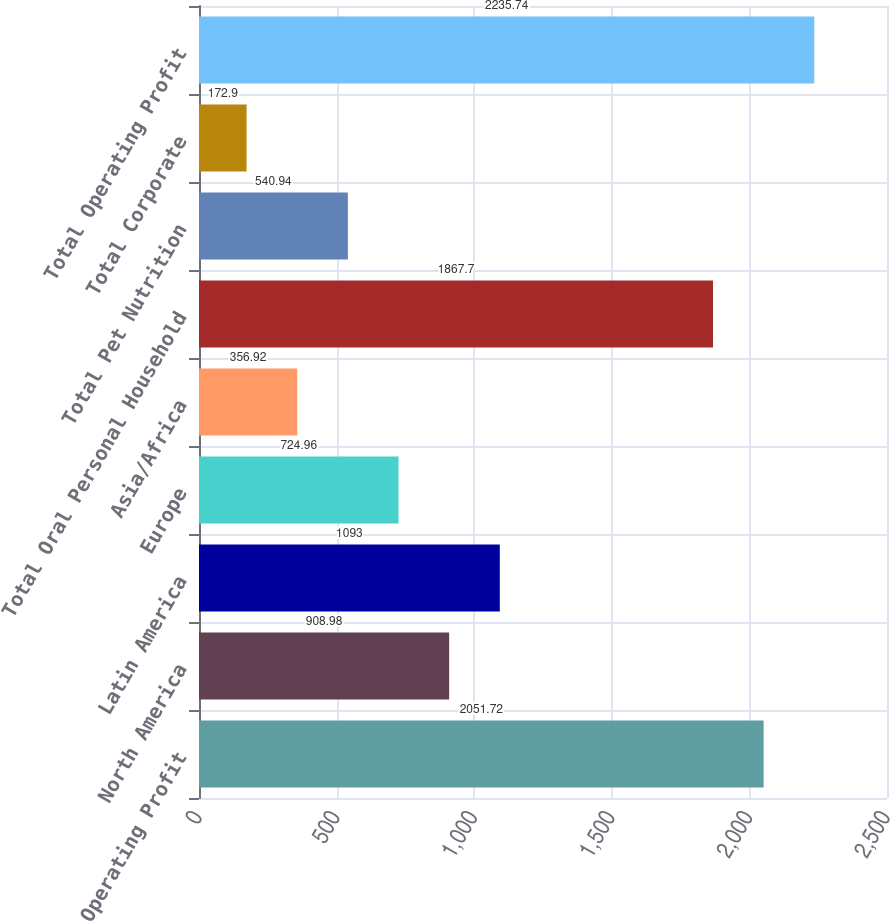<chart> <loc_0><loc_0><loc_500><loc_500><bar_chart><fcel>Operating Profit<fcel>North America<fcel>Latin America<fcel>Europe<fcel>Asia/Africa<fcel>Total Oral Personal Household<fcel>Total Pet Nutrition<fcel>Total Corporate<fcel>Total Operating Profit<nl><fcel>2051.72<fcel>908.98<fcel>1093<fcel>724.96<fcel>356.92<fcel>1867.7<fcel>540.94<fcel>172.9<fcel>2235.74<nl></chart> 